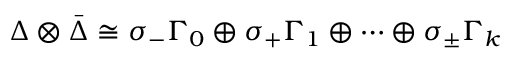<formula> <loc_0><loc_0><loc_500><loc_500>\Delta \otimes { \bar { \Delta } } \cong \sigma _ { - } \Gamma _ { 0 } \oplus \sigma _ { + } \Gamma _ { 1 } \oplus \dots \oplus \sigma _ { \pm } \Gamma _ { k }</formula> 